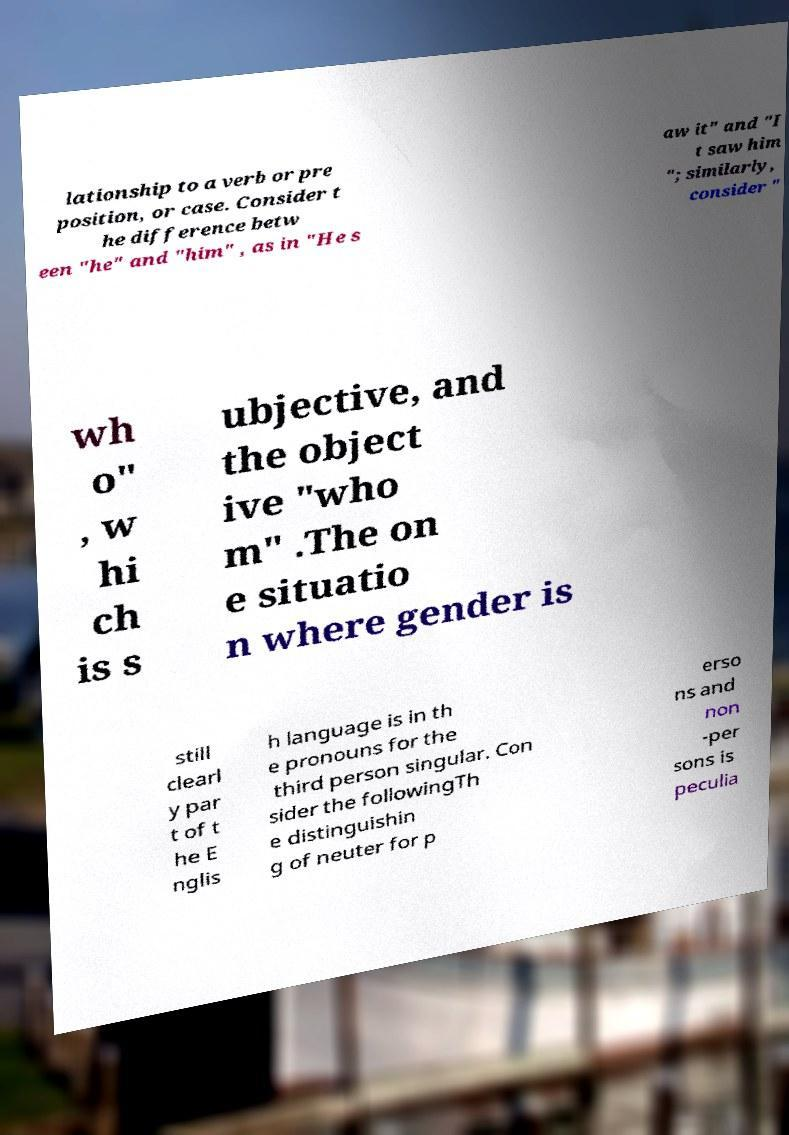Can you read and provide the text displayed in the image?This photo seems to have some interesting text. Can you extract and type it out for me? lationship to a verb or pre position, or case. Consider t he difference betw een "he" and "him" , as in "He s aw it" and "I t saw him "; similarly, consider " wh o" , w hi ch is s ubjective, and the object ive "who m" .The on e situatio n where gender is still clearl y par t of t he E nglis h language is in th e pronouns for the third person singular. Con sider the followingTh e distinguishin g of neuter for p erso ns and non -per sons is peculia 